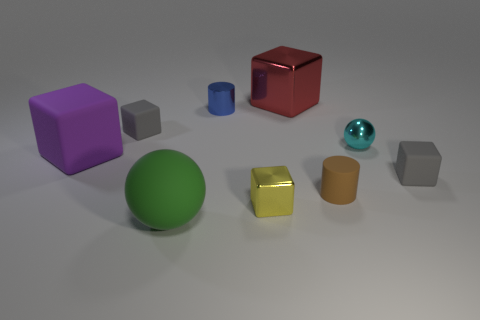Do any of the objects have reflective surfaces? Yes, the turquoise sphere and the golden cube appear to have glossy, reflective surfaces that catch the light and mirror their surroundings to some extent. 